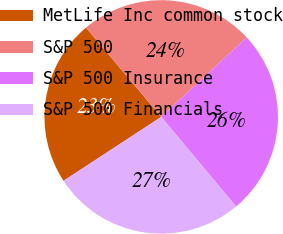Convert chart to OTSL. <chart><loc_0><loc_0><loc_500><loc_500><pie_chart><fcel>MetLife Inc common stock<fcel>S&P 500<fcel>S&P 500 Insurance<fcel>S&P 500 Financials<nl><fcel>23.08%<fcel>24.22%<fcel>25.84%<fcel>26.86%<nl></chart> 